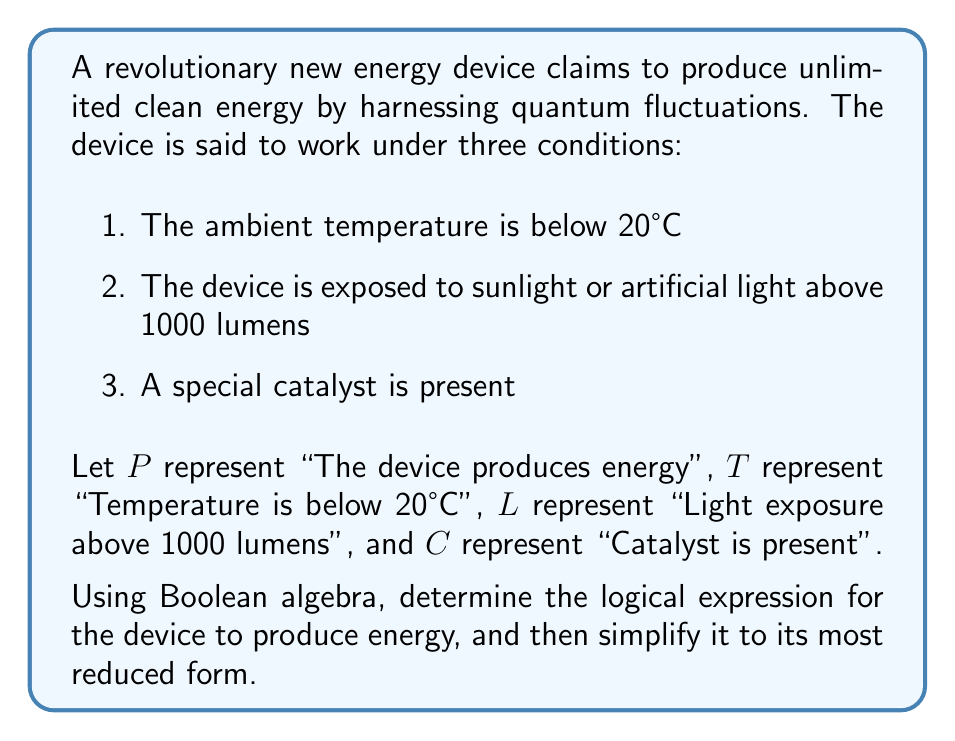Show me your answer to this math problem. To approach this problem, we'll follow these steps:

1. Construct the initial Boolean expression
2. Apply Boolean algebra laws to simplify the expression
3. Verify the simplification

Step 1: Constructing the initial Boolean expression

Based on the given conditions, the device produces energy when all three conditions are met. This can be represented as:

$P = T \wedge L \wedge C$

Step 2: Simplifying the expression

In this case, the expression is already in its simplest form. It's a conjunction (AND) of three variables, which cannot be reduced further using Boolean algebra laws.

Step 3: Verification

To verify that this is indeed the simplest form, we can consider the following laws of Boolean algebra:

- Idempotent law: $A \wedge A = A$
- Commutative law: $A \wedge B = B \wedge A$
- Associative law: $(A \wedge B) \wedge C = A \wedge (B \wedge C)$
- Distributive law: $A \wedge (B \vee C) = (A \wedge B) \vee (A \wedge C)$
- Absorption law: $A \wedge (A \vee B) = A$

None of these laws can be applied to further simplify our expression $T \wedge L \wedge C$.

From a critical perspective, this Boolean expression reveals that the device's functionality depends on the simultaneous presence of all three conditions. This interdependence might raise skepticism about the device's practicality and reliability in real-world scenarios where these conditions may not always coincide.
Answer: $P = T \wedge L \wedge C$ 